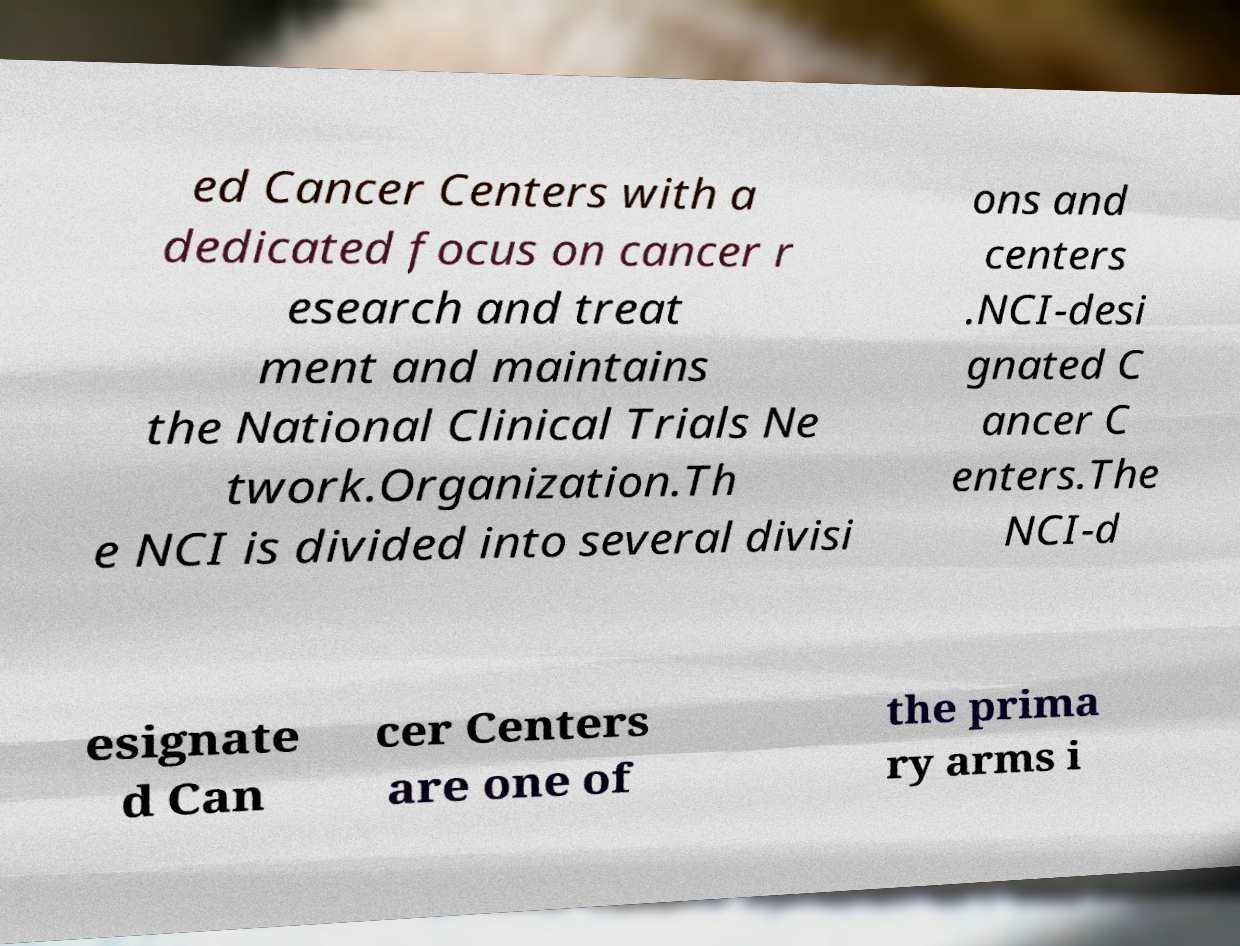Please identify and transcribe the text found in this image. ed Cancer Centers with a dedicated focus on cancer r esearch and treat ment and maintains the National Clinical Trials Ne twork.Organization.Th e NCI is divided into several divisi ons and centers .NCI-desi gnated C ancer C enters.The NCI-d esignate d Can cer Centers are one of the prima ry arms i 